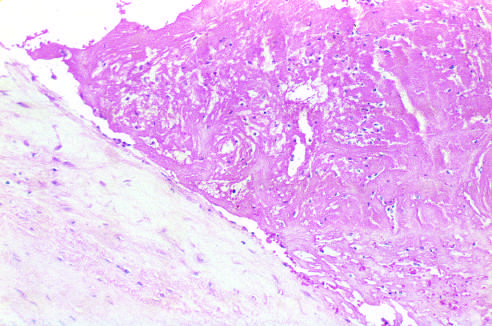s the thrombus only loosely attached to the cusp?
Answer the question using a single word or phrase. Yes 